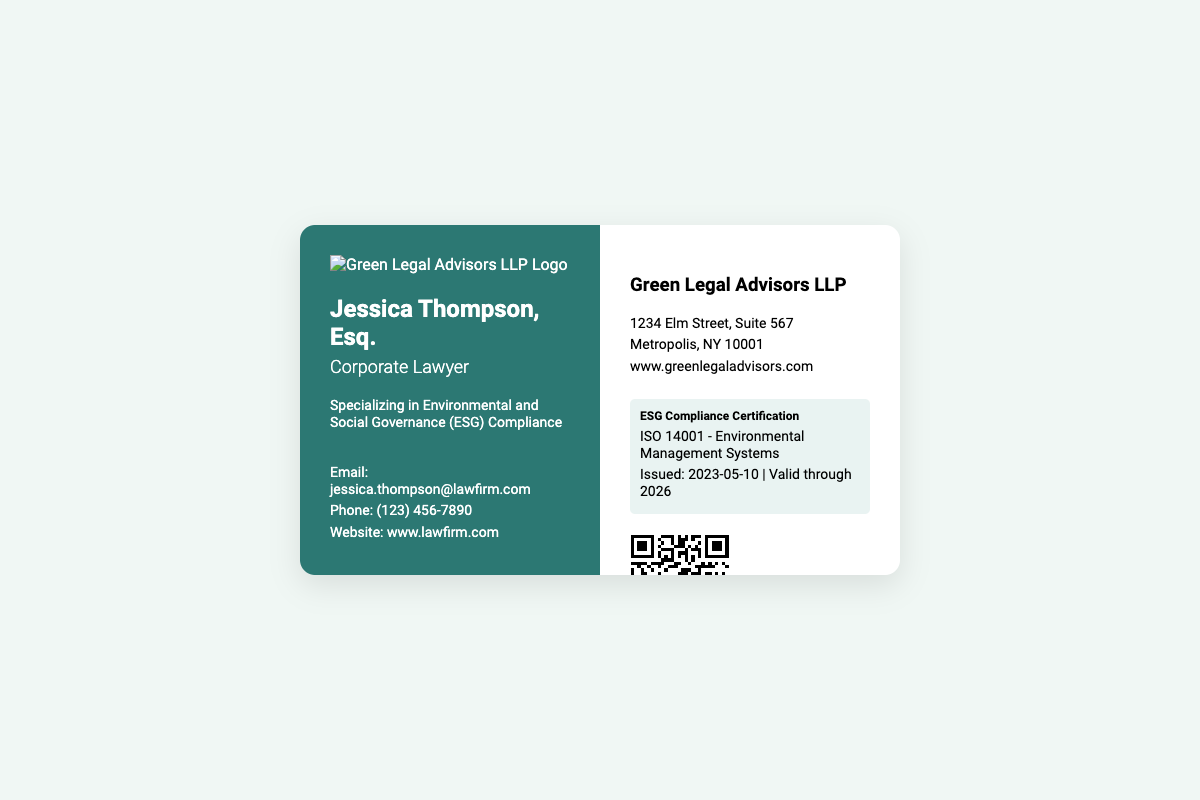What is the name of the corporate lawyer? The name of the corporate lawyer is presented prominently on the card.
Answer: Jessica Thompson What is the specialization of Jessica Thompson? The card states her area of expertise in a specific section.
Answer: Environmental and Social Governance (ESG) Compliance What is the phone number listed on the business card? The number appears in the contact info section of the card.
Answer: (123) 456-7890 What is the address of Green Legal Advisors LLP? The business address is provided on the right side of the card.
Answer: 1234 Elm Street, Suite 567 What certification is mentioned on the business card? The certification details are highlighted in a dedicated section.
Answer: ESG Compliance Certification When was the ESG Compliance Certification issued? The issuance date is included in the certification details.
Answer: 2023-05-10 What is the validity period of the ESG Compliance Certification? The validity duration is specified alongside the issuance date.
Answer: Valid through 2026 What does the QR code link to? The QR code is designed to direct users to a specific report referenced on the card.
Answer: Audit Report What organization is Jessica Thompson affiliated with? The name of the organization is presented prominently on the card.
Answer: Green Legal Advisors LLP 